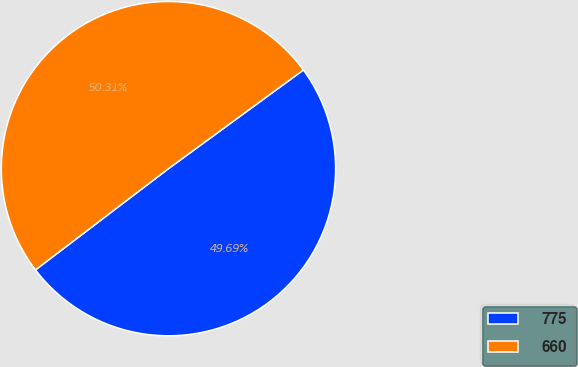Convert chart. <chart><loc_0><loc_0><loc_500><loc_500><pie_chart><fcel>775<fcel>660<nl><fcel>49.69%<fcel>50.31%<nl></chart> 